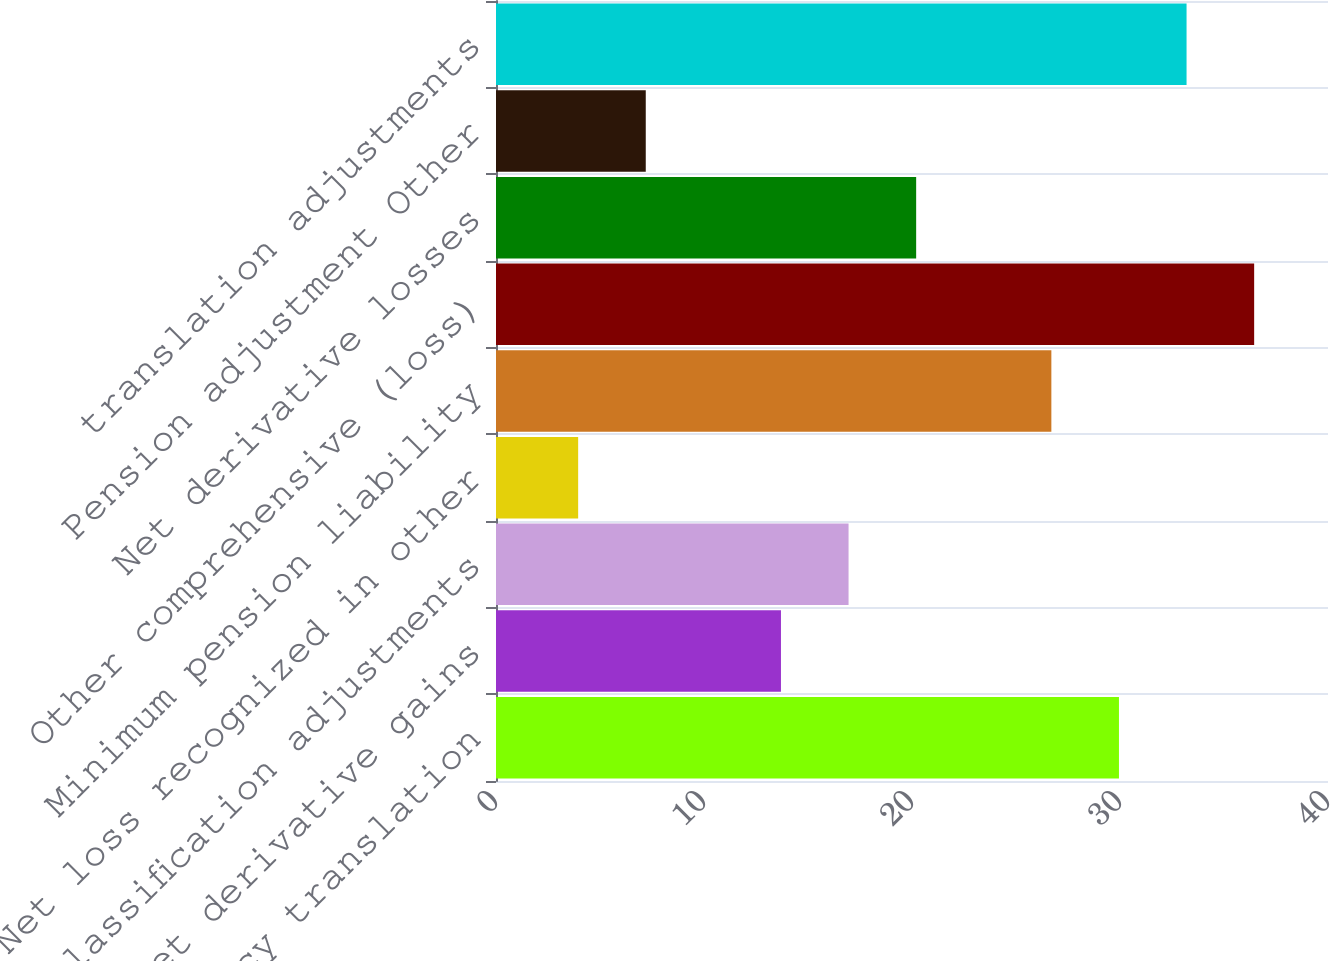Convert chart. <chart><loc_0><loc_0><loc_500><loc_500><bar_chart><fcel>Foreign currency translation<fcel>Net derivative gains<fcel>Reclassification adjustments<fcel>Net loss recognized in other<fcel>Minimum pension liability<fcel>Other comprehensive (loss)<fcel>Net derivative losses<fcel>Pension adjustment Other<fcel>translation adjustments<nl><fcel>29.95<fcel>13.7<fcel>16.95<fcel>3.95<fcel>26.7<fcel>36.45<fcel>20.2<fcel>7.2<fcel>33.2<nl></chart> 